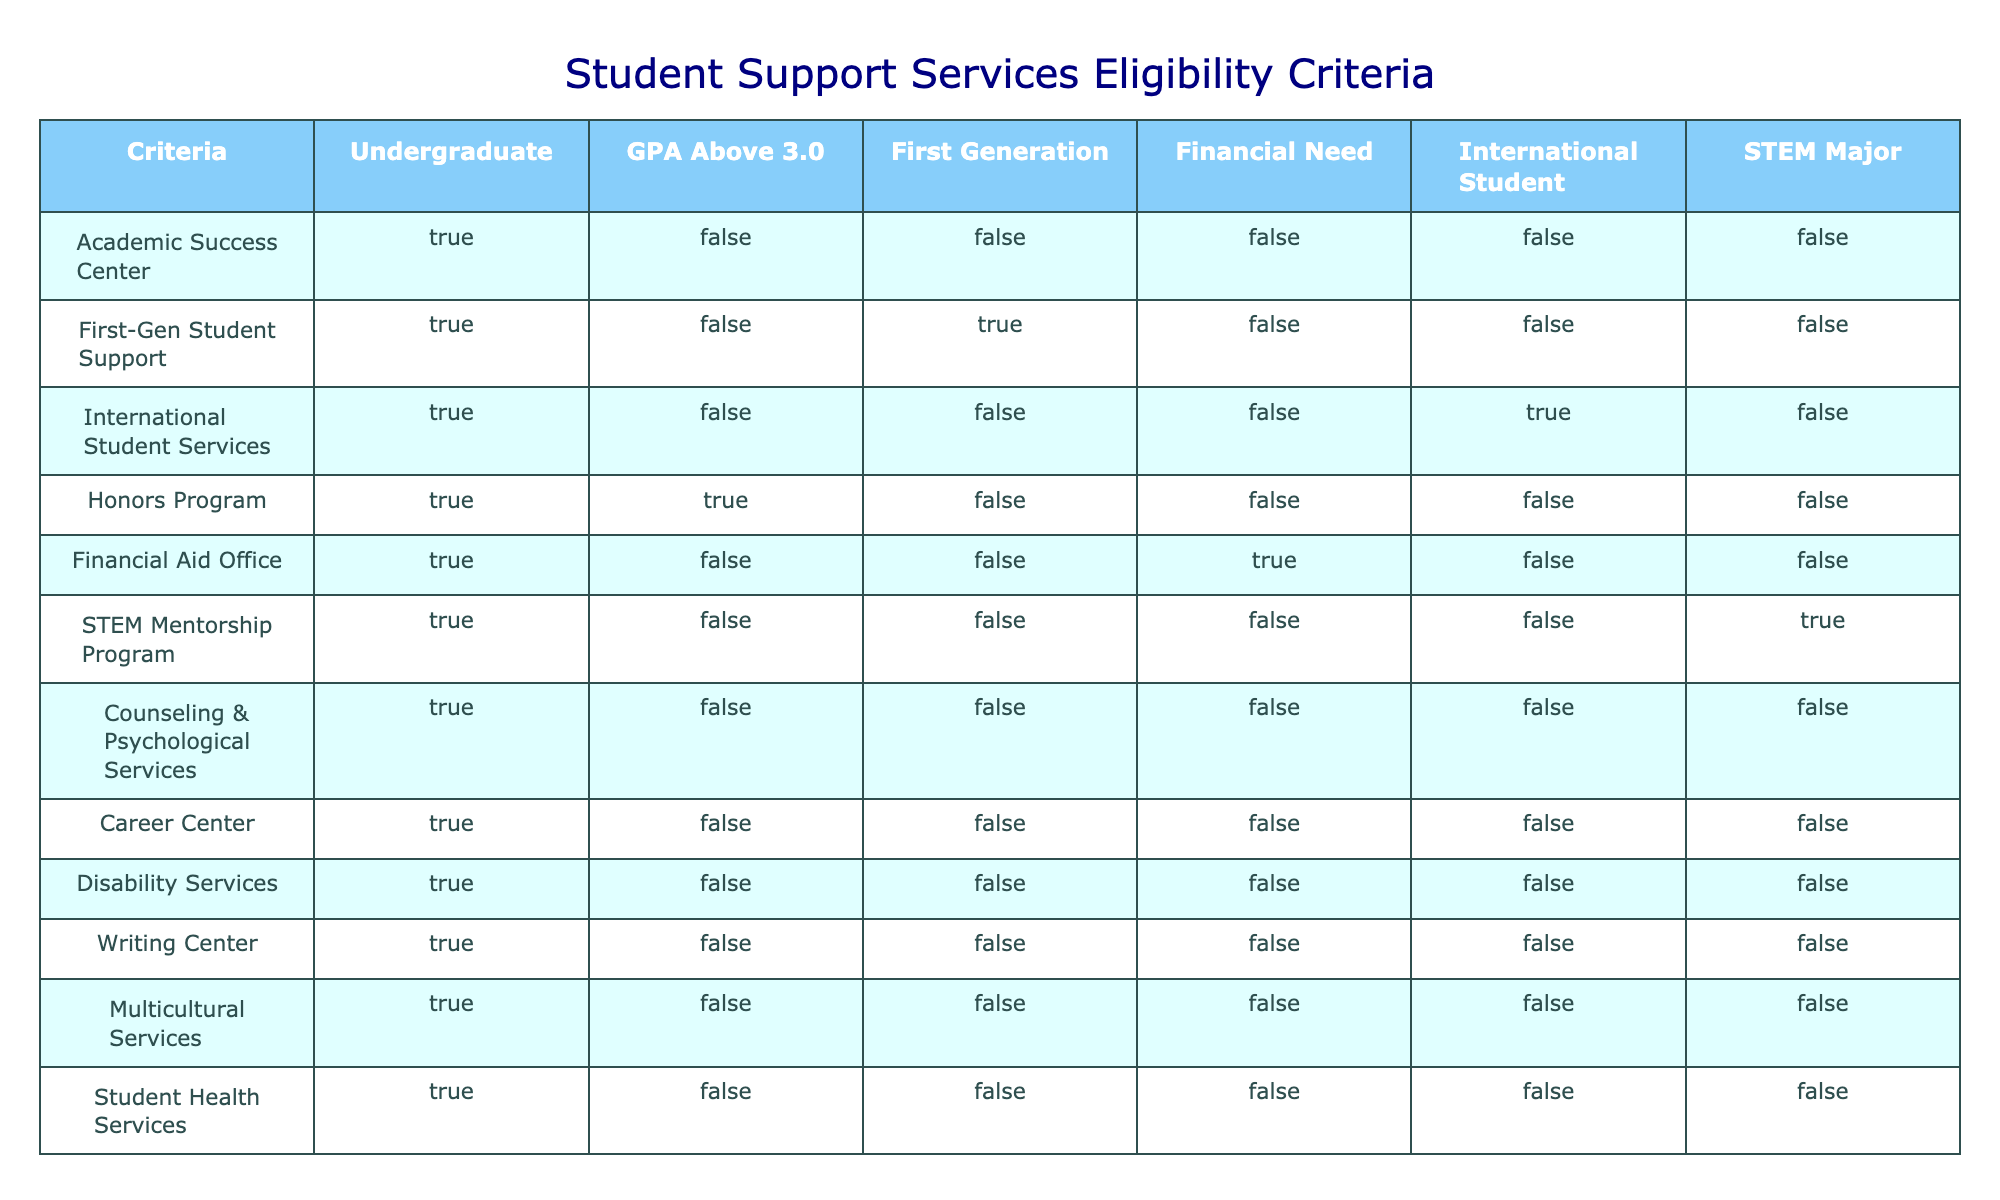What services are available for first-generation students? According to the table, the "First-Gen Student Support" service is available for first-generation students with a true eligibility value.
Answer: First-Gen Student Support Is there a service specifically for international students? Yes, "International Student Services" is the service provided for international students as indicated with a true eligibility value.
Answer: Yes How many services require a GPA above 3.0? The services that require a GPA above 3.0 are the "Honors Program." Thus, there is one service with this criterion.
Answer: 1 Is the STEM Mentorship Program available for undergraduate students in STEM majors? Yes, since the table indicates the STEM Mentorship Program has true eligibility for students who are STEM majors.
Answer: Yes What percentage of services listed in the table are available to undergraduate students? There are 12 student support services listed, and all of them are available to undergraduate students. Therefore, the percentage is (12/12) * 100 = 100%.
Answer: 100% How many support services are there for students with financial need? The only service for students with financial need is the "Financial Aid Office," making it one service in total.
Answer: 1 Which support services are available for undergraduate students who are not first-generation, have a GPA above 3.0, and do not have financial need? The "Honors Program" is the only service that matches the criteria of being available to undergraduates who are not first-generation and have a GPA above 3.0. It is eligible for this scenario.
Answer: Honors Program Are there any services that cater solely to STEM majors? Yes, the "STEM Mentorship Program" is exclusively available for STEM majors as shown by a true eligibility value under that criteria.
Answer: Yes How many services do not have any specific criteria like GPA, being first-generation, or having financial need? There are multiple services that don't cater to these criteria directly; it's noted that services like "Counseling & Psychological Services," "Career Center," "Disability Services," "Writing Center," "Multicultural Services," and "Student Health Services" do not require these conditions. Counting those gives us six services.
Answer: 6 